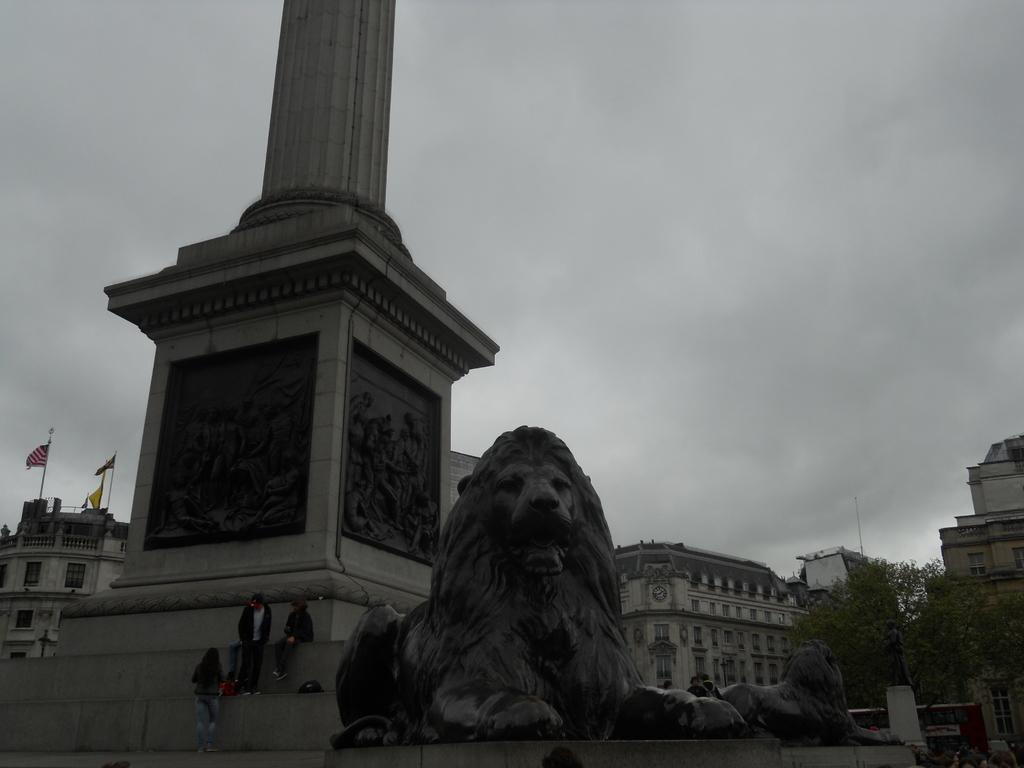What can be seen in the front portion of the image? In the front portion of the image, there are pillars, people, and statues. What is present in the background portion of the image? In the background portion of the image, there are flags, buildings, a statue, a tree, and the sky. How would you describe the sky in the image? The sky in the image appears to be cloudy. What type of business is being conducted near the dock in the image? There is no dock or business present in the image. What type of jeans are the people wearing in the image? The provided facts do not mention any clothing, including jeans, so we cannot determine what type of jeans the people are wearing. 